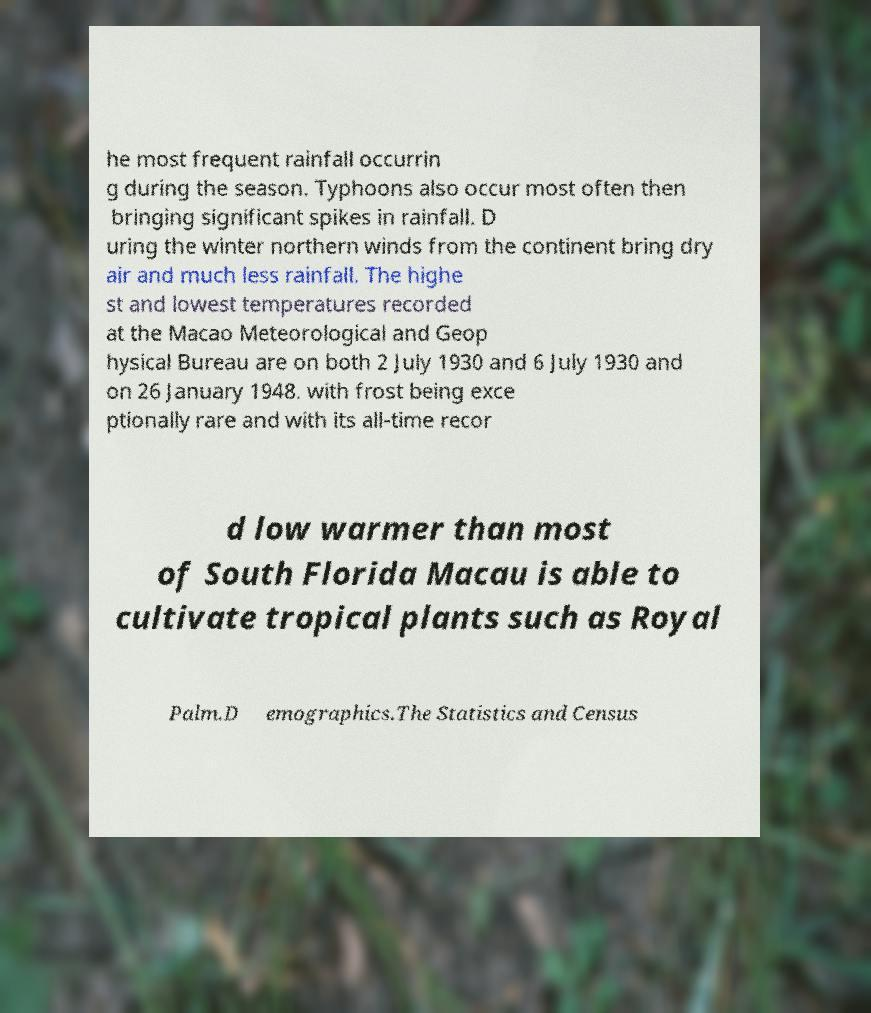There's text embedded in this image that I need extracted. Can you transcribe it verbatim? he most frequent rainfall occurrin g during the season. Typhoons also occur most often then bringing significant spikes in rainfall. D uring the winter northern winds from the continent bring dry air and much less rainfall. The highe st and lowest temperatures recorded at the Macao Meteorological and Geop hysical Bureau are on both 2 July 1930 and 6 July 1930 and on 26 January 1948. with frost being exce ptionally rare and with its all-time recor d low warmer than most of South Florida Macau is able to cultivate tropical plants such as Royal Palm.D emographics.The Statistics and Census 